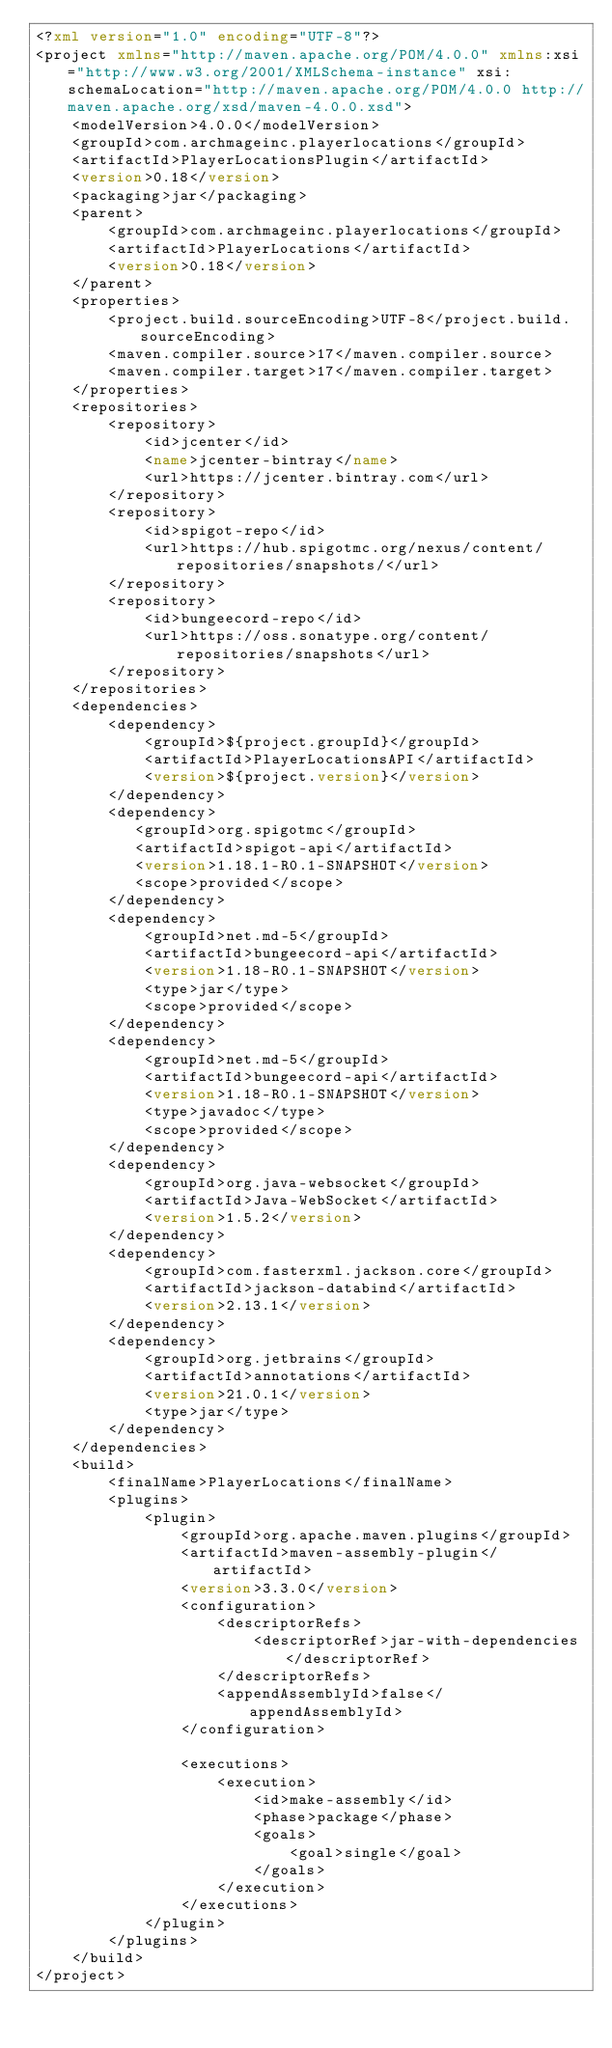Convert code to text. <code><loc_0><loc_0><loc_500><loc_500><_XML_><?xml version="1.0" encoding="UTF-8"?>
<project xmlns="http://maven.apache.org/POM/4.0.0" xmlns:xsi="http://www.w3.org/2001/XMLSchema-instance" xsi:schemaLocation="http://maven.apache.org/POM/4.0.0 http://maven.apache.org/xsd/maven-4.0.0.xsd">
    <modelVersion>4.0.0</modelVersion>
    <groupId>com.archmageinc.playerlocations</groupId>
    <artifactId>PlayerLocationsPlugin</artifactId>
    <version>0.18</version>
    <packaging>jar</packaging>
    <parent>
        <groupId>com.archmageinc.playerlocations</groupId>
        <artifactId>PlayerLocations</artifactId>
        <version>0.18</version>
    </parent>
    <properties>
        <project.build.sourceEncoding>UTF-8</project.build.sourceEncoding>
        <maven.compiler.source>17</maven.compiler.source>
        <maven.compiler.target>17</maven.compiler.target>
    </properties>
    <repositories>
        <repository>
            <id>jcenter</id>
            <name>jcenter-bintray</name>
            <url>https://jcenter.bintray.com</url>
        </repository>
        <repository>
            <id>spigot-repo</id>
            <url>https://hub.spigotmc.org/nexus/content/repositories/snapshots/</url>
        </repository>
        <repository>
            <id>bungeecord-repo</id>
            <url>https://oss.sonatype.org/content/repositories/snapshots</url>
        </repository>
    </repositories>
    <dependencies>
        <dependency>
            <groupId>${project.groupId}</groupId>
            <artifactId>PlayerLocationsAPI</artifactId>
            <version>${project.version}</version>
        </dependency>
        <dependency>
           <groupId>org.spigotmc</groupId>
           <artifactId>spigot-api</artifactId>
           <version>1.18.1-R0.1-SNAPSHOT</version>
           <scope>provided</scope>
        </dependency>
        <dependency>
            <groupId>net.md-5</groupId>
            <artifactId>bungeecord-api</artifactId>
            <version>1.18-R0.1-SNAPSHOT</version>
            <type>jar</type>
            <scope>provided</scope>
        </dependency>
        <dependency>
            <groupId>net.md-5</groupId>
            <artifactId>bungeecord-api</artifactId>
            <version>1.18-R0.1-SNAPSHOT</version>
            <type>javadoc</type>
            <scope>provided</scope>
        </dependency>
        <dependency>
            <groupId>org.java-websocket</groupId>
            <artifactId>Java-WebSocket</artifactId>
            <version>1.5.2</version>
        </dependency>
        <dependency>
            <groupId>com.fasterxml.jackson.core</groupId>
            <artifactId>jackson-databind</artifactId>
            <version>2.13.1</version>
        </dependency>
        <dependency>
            <groupId>org.jetbrains</groupId>
            <artifactId>annotations</artifactId>
            <version>21.0.1</version>
            <type>jar</type>
        </dependency>
    </dependencies>
    <build>
        <finalName>PlayerLocations</finalName>
        <plugins>
            <plugin>
                <groupId>org.apache.maven.plugins</groupId>
                <artifactId>maven-assembly-plugin</artifactId>
                <version>3.3.0</version>
                <configuration>
                    <descriptorRefs>
                        <descriptorRef>jar-with-dependencies</descriptorRef>
                    </descriptorRefs>
                    <appendAssemblyId>false</appendAssemblyId>
                </configuration>

                <executions>
                    <execution>
                        <id>make-assembly</id>
                        <phase>package</phase>
                        <goals>
                            <goal>single</goal>
                        </goals>
                    </execution>
                </executions>
            </plugin>
        </plugins>
    </build>
</project></code> 